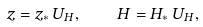Convert formula to latex. <formula><loc_0><loc_0><loc_500><loc_500>z = z _ { * } \, U _ { H } , \quad H = H _ { * } \, U _ { H } ,</formula> 